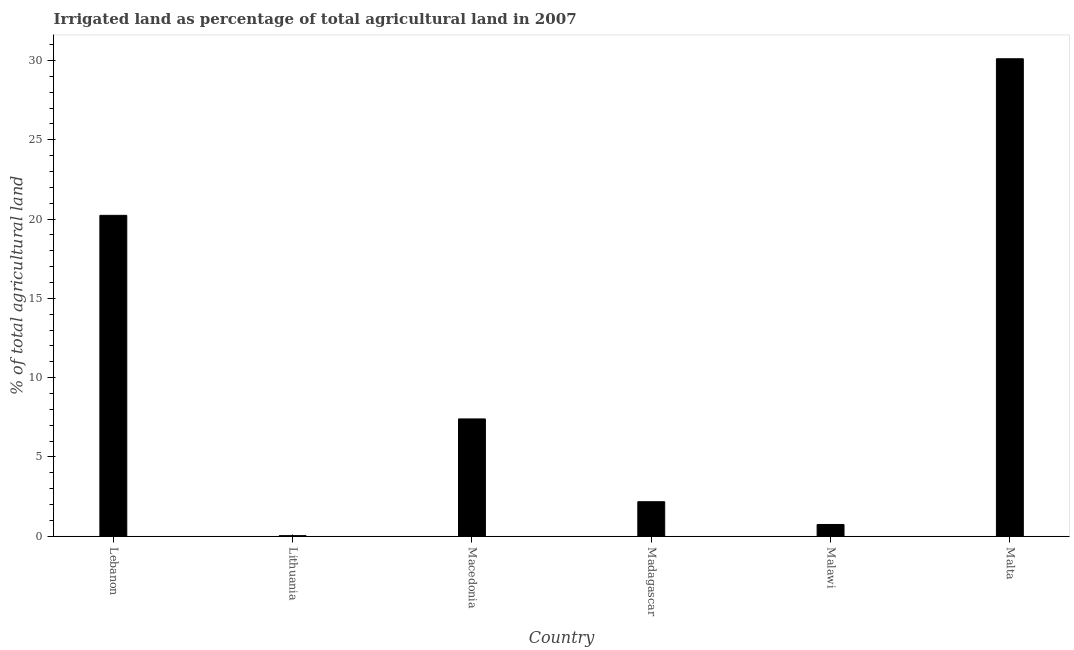What is the title of the graph?
Make the answer very short. Irrigated land as percentage of total agricultural land in 2007. What is the label or title of the X-axis?
Your response must be concise. Country. What is the label or title of the Y-axis?
Your response must be concise. % of total agricultural land. What is the percentage of agricultural irrigated land in Macedonia?
Provide a succinct answer. 7.4. Across all countries, what is the maximum percentage of agricultural irrigated land?
Your answer should be compact. 30.11. Across all countries, what is the minimum percentage of agricultural irrigated land?
Offer a very short reply. 0.04. In which country was the percentage of agricultural irrigated land maximum?
Ensure brevity in your answer.  Malta. In which country was the percentage of agricultural irrigated land minimum?
Make the answer very short. Lithuania. What is the sum of the percentage of agricultural irrigated land?
Provide a succinct answer. 60.69. What is the difference between the percentage of agricultural irrigated land in Malawi and Malta?
Offer a very short reply. -29.36. What is the average percentage of agricultural irrigated land per country?
Provide a succinct answer. 10.12. What is the median percentage of agricultural irrigated land?
Provide a succinct answer. 4.79. In how many countries, is the percentage of agricultural irrigated land greater than 30 %?
Make the answer very short. 1. What is the ratio of the percentage of agricultural irrigated land in Lebanon to that in Macedonia?
Give a very brief answer. 2.73. Is the percentage of agricultural irrigated land in Lithuania less than that in Malta?
Ensure brevity in your answer.  Yes. What is the difference between the highest and the second highest percentage of agricultural irrigated land?
Give a very brief answer. 9.87. Is the sum of the percentage of agricultural irrigated land in Lithuania and Madagascar greater than the maximum percentage of agricultural irrigated land across all countries?
Keep it short and to the point. No. What is the difference between the highest and the lowest percentage of agricultural irrigated land?
Make the answer very short. 30.07. Are all the bars in the graph horizontal?
Give a very brief answer. No. What is the % of total agricultural land in Lebanon?
Ensure brevity in your answer.  20.23. What is the % of total agricultural land of Lithuania?
Offer a terse response. 0.04. What is the % of total agricultural land in Macedonia?
Offer a very short reply. 7.4. What is the % of total agricultural land in Madagascar?
Offer a terse response. 2.18. What is the % of total agricultural land in Malawi?
Provide a short and direct response. 0.74. What is the % of total agricultural land of Malta?
Make the answer very short. 30.11. What is the difference between the % of total agricultural land in Lebanon and Lithuania?
Offer a terse response. 20.2. What is the difference between the % of total agricultural land in Lebanon and Macedonia?
Give a very brief answer. 12.84. What is the difference between the % of total agricultural land in Lebanon and Madagascar?
Provide a succinct answer. 18.06. What is the difference between the % of total agricultural land in Lebanon and Malawi?
Offer a terse response. 19.49. What is the difference between the % of total agricultural land in Lebanon and Malta?
Provide a short and direct response. -9.87. What is the difference between the % of total agricultural land in Lithuania and Macedonia?
Keep it short and to the point. -7.36. What is the difference between the % of total agricultural land in Lithuania and Madagascar?
Provide a short and direct response. -2.14. What is the difference between the % of total agricultural land in Lithuania and Malawi?
Your answer should be very brief. -0.71. What is the difference between the % of total agricultural land in Lithuania and Malta?
Make the answer very short. -30.07. What is the difference between the % of total agricultural land in Macedonia and Madagascar?
Your answer should be very brief. 5.22. What is the difference between the % of total agricultural land in Macedonia and Malawi?
Make the answer very short. 6.66. What is the difference between the % of total agricultural land in Macedonia and Malta?
Your response must be concise. -22.71. What is the difference between the % of total agricultural land in Madagascar and Malawi?
Make the answer very short. 1.43. What is the difference between the % of total agricultural land in Madagascar and Malta?
Make the answer very short. -27.93. What is the difference between the % of total agricultural land in Malawi and Malta?
Keep it short and to the point. -29.37. What is the ratio of the % of total agricultural land in Lebanon to that in Lithuania?
Provide a short and direct response. 545.47. What is the ratio of the % of total agricultural land in Lebanon to that in Macedonia?
Offer a very short reply. 2.73. What is the ratio of the % of total agricultural land in Lebanon to that in Madagascar?
Provide a succinct answer. 9.3. What is the ratio of the % of total agricultural land in Lebanon to that in Malawi?
Ensure brevity in your answer.  27.26. What is the ratio of the % of total agricultural land in Lebanon to that in Malta?
Your answer should be compact. 0.67. What is the ratio of the % of total agricultural land in Lithuania to that in Macedonia?
Offer a terse response. 0.01. What is the ratio of the % of total agricultural land in Lithuania to that in Madagascar?
Ensure brevity in your answer.  0.02. What is the ratio of the % of total agricultural land in Macedonia to that in Madagascar?
Make the answer very short. 3.4. What is the ratio of the % of total agricultural land in Macedonia to that in Malawi?
Ensure brevity in your answer.  9.97. What is the ratio of the % of total agricultural land in Macedonia to that in Malta?
Keep it short and to the point. 0.25. What is the ratio of the % of total agricultural land in Madagascar to that in Malawi?
Give a very brief answer. 2.93. What is the ratio of the % of total agricultural land in Madagascar to that in Malta?
Give a very brief answer. 0.07. What is the ratio of the % of total agricultural land in Malawi to that in Malta?
Provide a succinct answer. 0.03. 